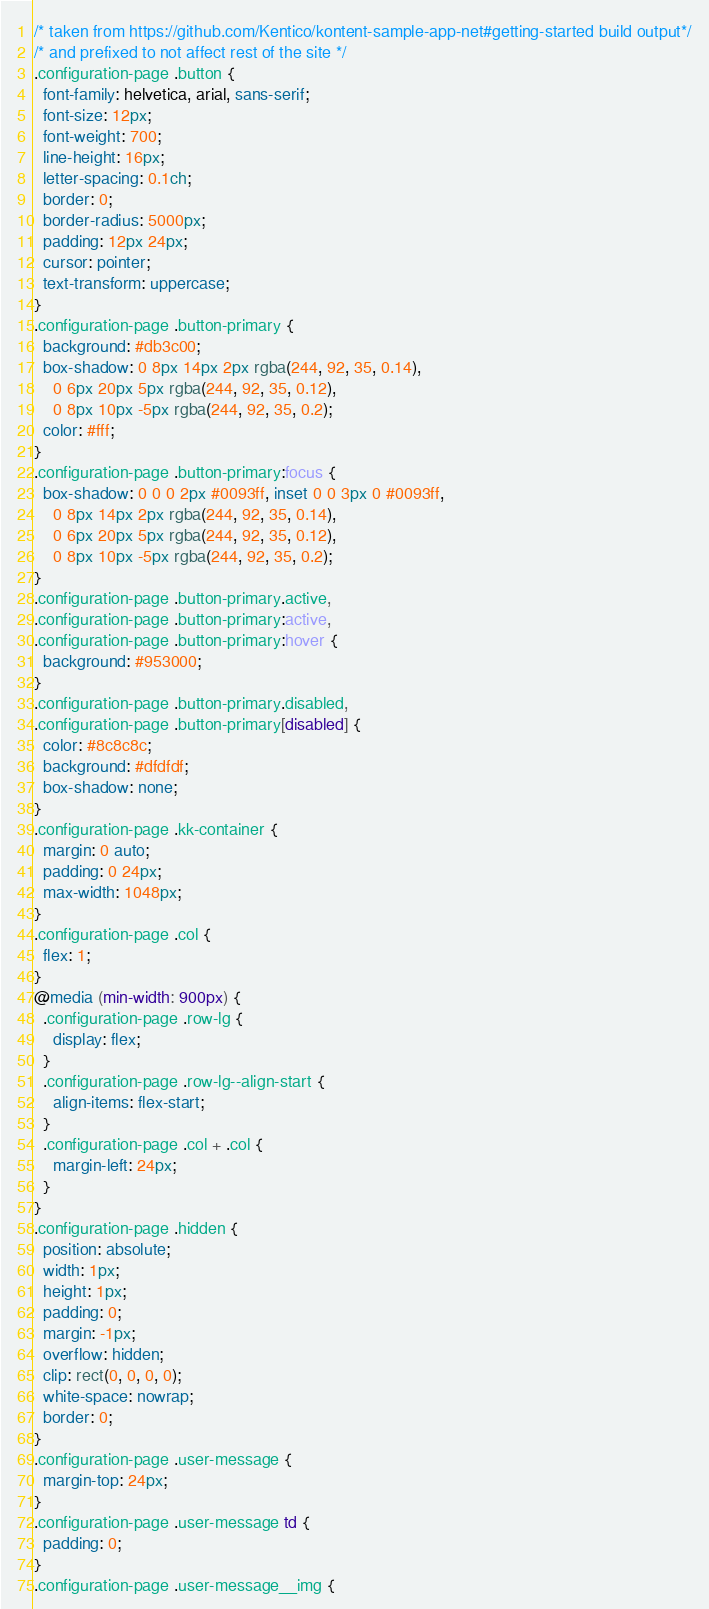<code> <loc_0><loc_0><loc_500><loc_500><_CSS_>/* taken from https://github.com/Kentico/kontent-sample-app-net#getting-started build output*/
/* and prefixed to not affect rest of the site */
.configuration-page .button {
  font-family: helvetica, arial, sans-serif;
  font-size: 12px;
  font-weight: 700;
  line-height: 16px;
  letter-spacing: 0.1ch;
  border: 0;
  border-radius: 5000px;
  padding: 12px 24px;
  cursor: pointer;
  text-transform: uppercase;
}
.configuration-page .button-primary {
  background: #db3c00;
  box-shadow: 0 8px 14px 2px rgba(244, 92, 35, 0.14),
    0 6px 20px 5px rgba(244, 92, 35, 0.12),
    0 8px 10px -5px rgba(244, 92, 35, 0.2);
  color: #fff;
}
.configuration-page .button-primary:focus {
  box-shadow: 0 0 0 2px #0093ff, inset 0 0 3px 0 #0093ff,
    0 8px 14px 2px rgba(244, 92, 35, 0.14),
    0 6px 20px 5px rgba(244, 92, 35, 0.12),
    0 8px 10px -5px rgba(244, 92, 35, 0.2);
}
.configuration-page .button-primary.active,
.configuration-page .button-primary:active,
.configuration-page .button-primary:hover {
  background: #953000;
}
.configuration-page .button-primary.disabled,
.configuration-page .button-primary[disabled] {
  color: #8c8c8c;
  background: #dfdfdf;
  box-shadow: none;
}
.configuration-page .kk-container {
  margin: 0 auto;
  padding: 0 24px;
  max-width: 1048px;
}
.configuration-page .col {
  flex: 1;
}
@media (min-width: 900px) {
  .configuration-page .row-lg {
    display: flex;
  }
  .configuration-page .row-lg--align-start {
    align-items: flex-start;
  }
  .configuration-page .col + .col {
    margin-left: 24px;
  }
}
.configuration-page .hidden {
  position: absolute;
  width: 1px;
  height: 1px;
  padding: 0;
  margin: -1px;
  overflow: hidden;
  clip: rect(0, 0, 0, 0);
  white-space: nowrap;
  border: 0;
}
.configuration-page .user-message {
  margin-top: 24px;
}
.configuration-page .user-message td {
  padding: 0;
}
.configuration-page .user-message__img {</code> 